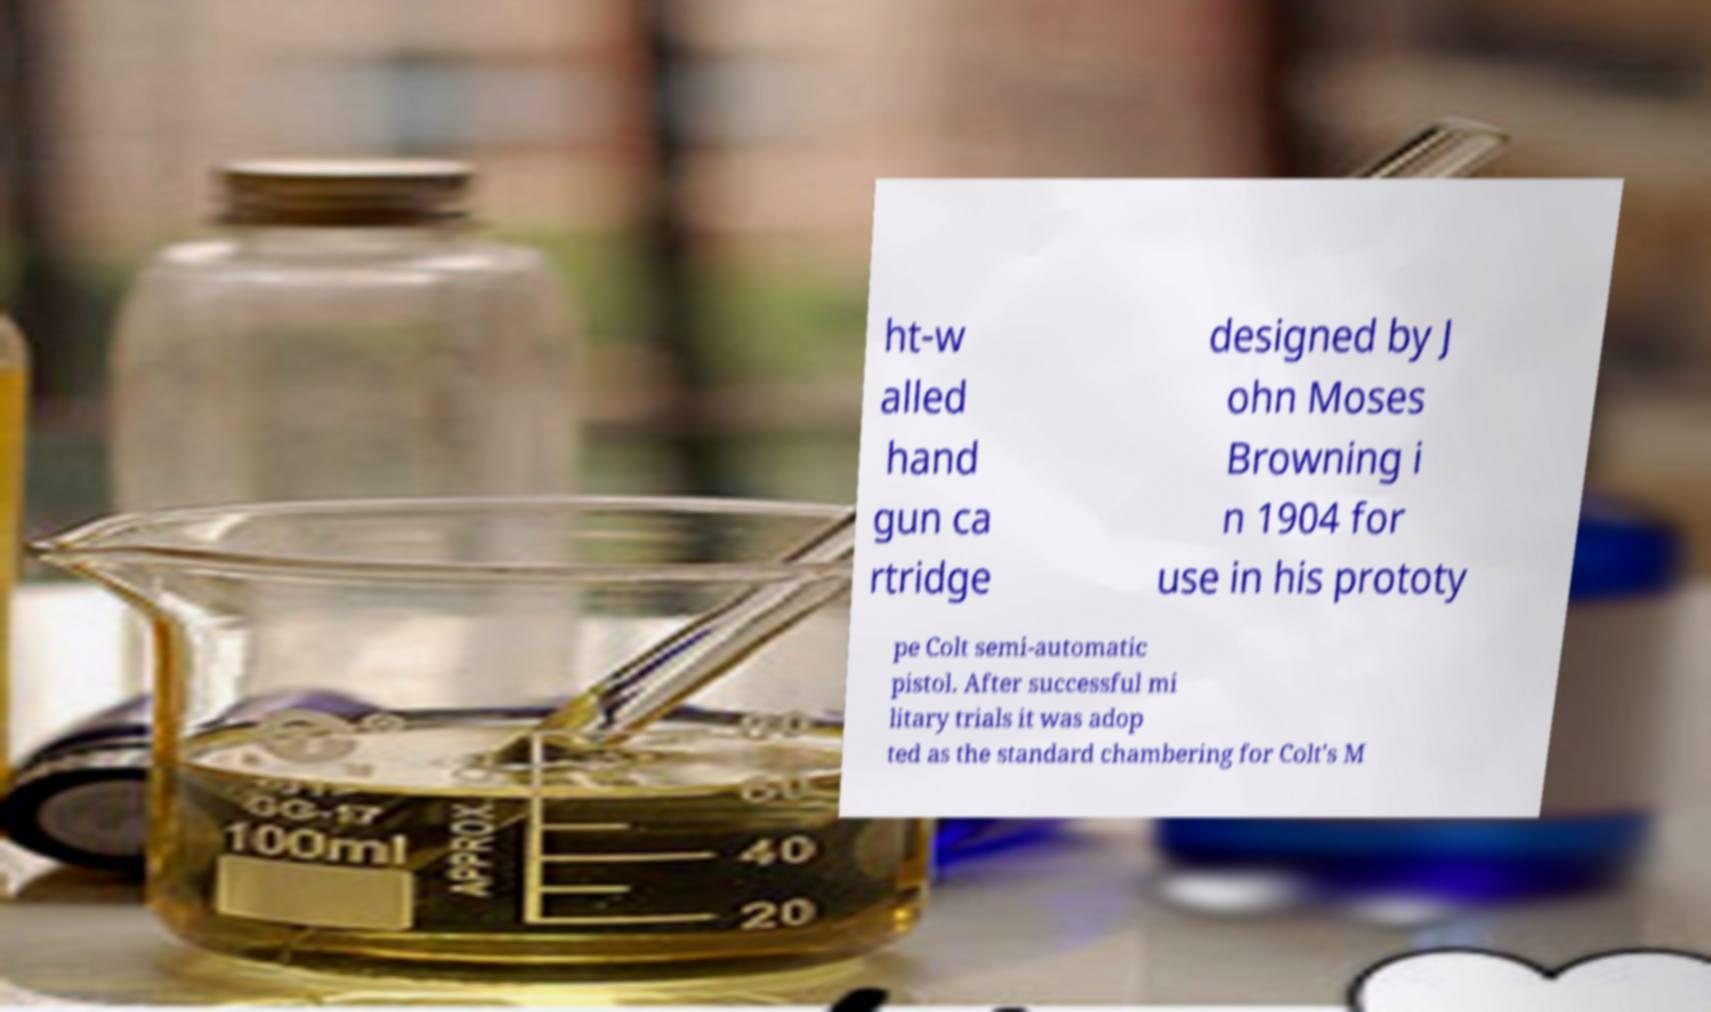Can you accurately transcribe the text from the provided image for me? ht-w alled hand gun ca rtridge designed by J ohn Moses Browning i n 1904 for use in his prototy pe Colt semi-automatic pistol. After successful mi litary trials it was adop ted as the standard chambering for Colt's M 